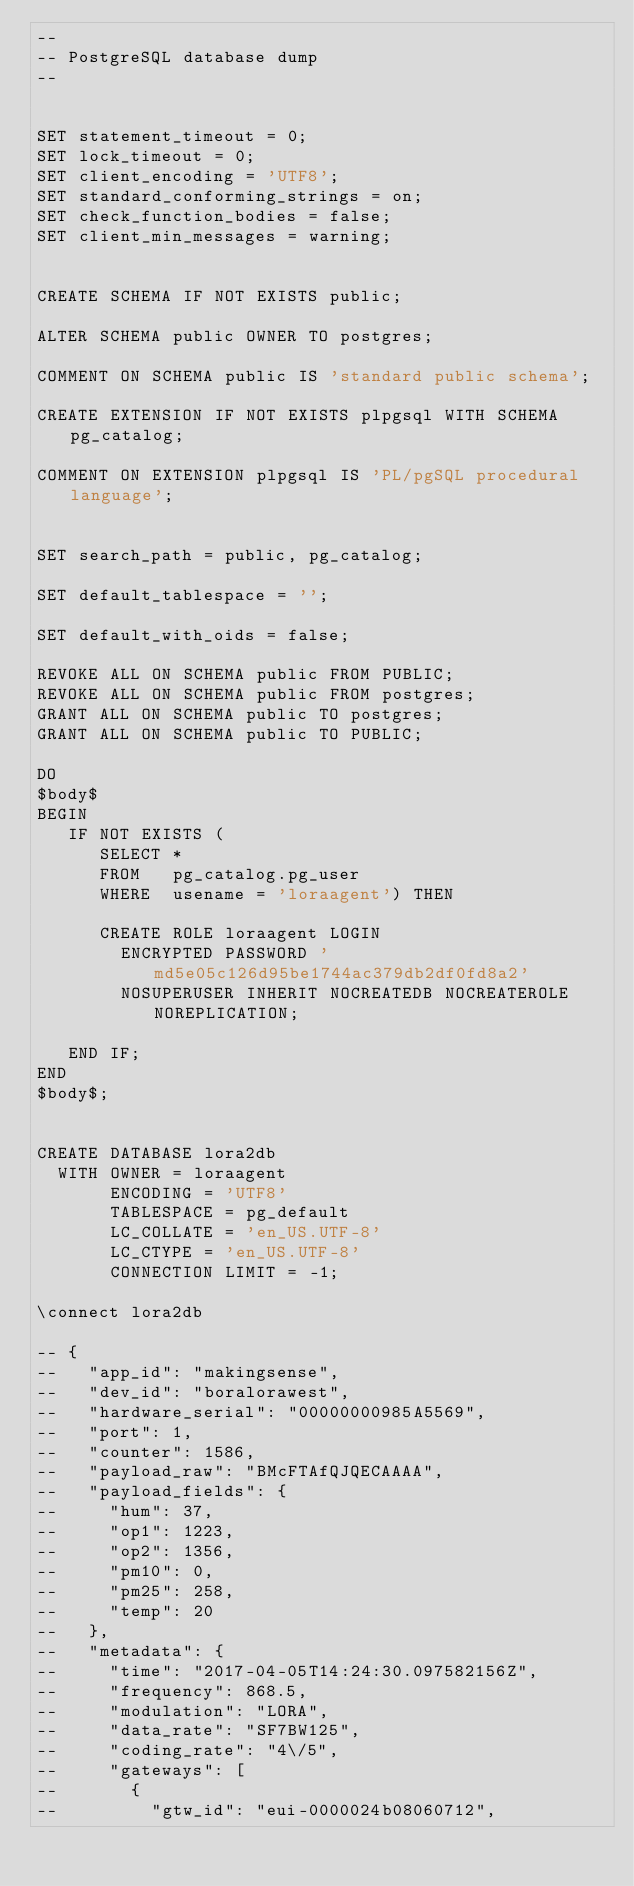Convert code to text. <code><loc_0><loc_0><loc_500><loc_500><_SQL_>--
-- PostgreSQL database dump
--


SET statement_timeout = 0;
SET lock_timeout = 0;
SET client_encoding = 'UTF8';
SET standard_conforming_strings = on;
SET check_function_bodies = false;
SET client_min_messages = warning;


CREATE SCHEMA IF NOT EXISTS public;

ALTER SCHEMA public OWNER TO postgres;

COMMENT ON SCHEMA public IS 'standard public schema';

CREATE EXTENSION IF NOT EXISTS plpgsql WITH SCHEMA pg_catalog;

COMMENT ON EXTENSION plpgsql IS 'PL/pgSQL procedural language';


SET search_path = public, pg_catalog;

SET default_tablespace = '';

SET default_with_oids = false;

REVOKE ALL ON SCHEMA public FROM PUBLIC;
REVOKE ALL ON SCHEMA public FROM postgres;
GRANT ALL ON SCHEMA public TO postgres;
GRANT ALL ON SCHEMA public TO PUBLIC;

DO
$body$
BEGIN
   IF NOT EXISTS (
      SELECT *
      FROM   pg_catalog.pg_user
      WHERE  usename = 'loraagent') THEN

      CREATE ROLE loraagent LOGIN
        ENCRYPTED PASSWORD 'md5e05c126d95be1744ac379db2df0fd8a2'
        NOSUPERUSER INHERIT NOCREATEDB NOCREATEROLE NOREPLICATION;

   END IF;
END
$body$;


CREATE DATABASE lora2db
  WITH OWNER = loraagent
       ENCODING = 'UTF8'
       TABLESPACE = pg_default
       LC_COLLATE = 'en_US.UTF-8'
       LC_CTYPE = 'en_US.UTF-8'
       CONNECTION LIMIT = -1;

\connect lora2db

-- {
--   "app_id": "makingsense",
--   "dev_id": "boralorawest",
--   "hardware_serial": "00000000985A5569",
--   "port": 1,
--   "counter": 1586,
--   "payload_raw": "BMcFTAfQJQECAAAA",
--   "payload_fields": {
--     "hum": 37,
--     "op1": 1223,
--     "op2": 1356,
--     "pm10": 0,
--     "pm25": 258,
--     "temp": 20
--   },
--   "metadata": {
--     "time": "2017-04-05T14:24:30.097582156Z",
--     "frequency": 868.5,
--     "modulation": "LORA",
--     "data_rate": "SF7BW125",
--     "coding_rate": "4\/5",
--     "gateways": [
--       {
--         "gtw_id": "eui-0000024b08060712",</code> 